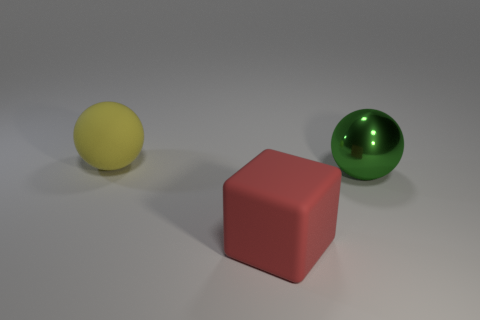Add 2 red blocks. How many objects exist? 5 Subtract all blocks. How many objects are left? 2 Add 1 big green objects. How many big green objects are left? 2 Add 3 large metal spheres. How many large metal spheres exist? 4 Subtract 0 cyan blocks. How many objects are left? 3 Subtract all small green blocks. Subtract all large rubber objects. How many objects are left? 1 